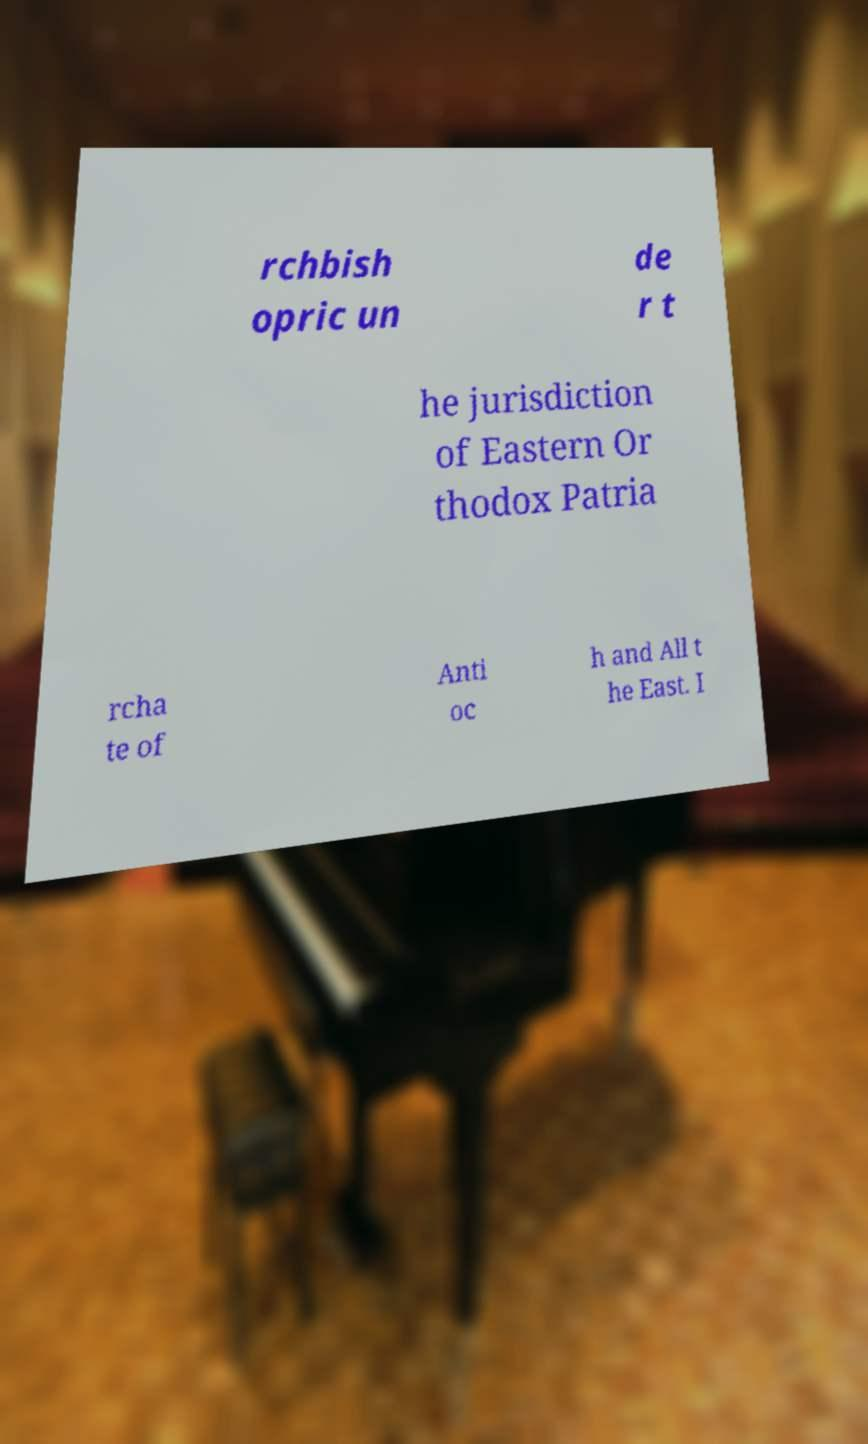Could you assist in decoding the text presented in this image and type it out clearly? rchbish opric un de r t he jurisdiction of Eastern Or thodox Patria rcha te of Anti oc h and All t he East. I 